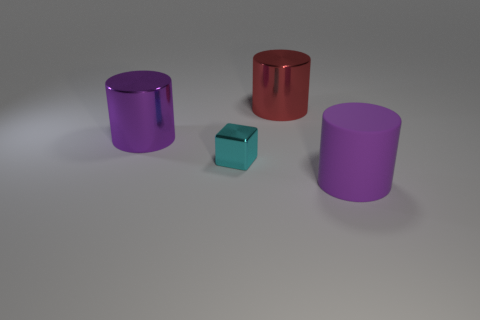There is a matte thing; is it the same color as the large metallic object to the left of the small cyan cube?
Provide a succinct answer. Yes. What number of other objects are there of the same size as the red thing?
Your response must be concise. 2. What is the shape of the purple thing to the right of the big object that is left of the big cylinder behind the purple shiny cylinder?
Provide a short and direct response. Cylinder. Is the size of the purple matte thing the same as the purple cylinder left of the rubber cylinder?
Your answer should be very brief. Yes. There is a metallic thing that is both behind the metallic block and right of the big purple shiny cylinder; what is its color?
Your answer should be very brief. Red. What number of other things are there of the same shape as the small cyan thing?
Your answer should be very brief. 0. There is a object left of the shiny block; is its color the same as the metallic object that is to the right of the tiny shiny thing?
Give a very brief answer. No. There is a purple cylinder that is left of the red object; is its size the same as the cyan thing in front of the large red object?
Offer a terse response. No. Are there any other things that are the same material as the small cyan thing?
Give a very brief answer. Yes. What material is the purple cylinder that is in front of the purple object that is on the left side of the large purple object to the right of the purple metal cylinder?
Your answer should be very brief. Rubber. 